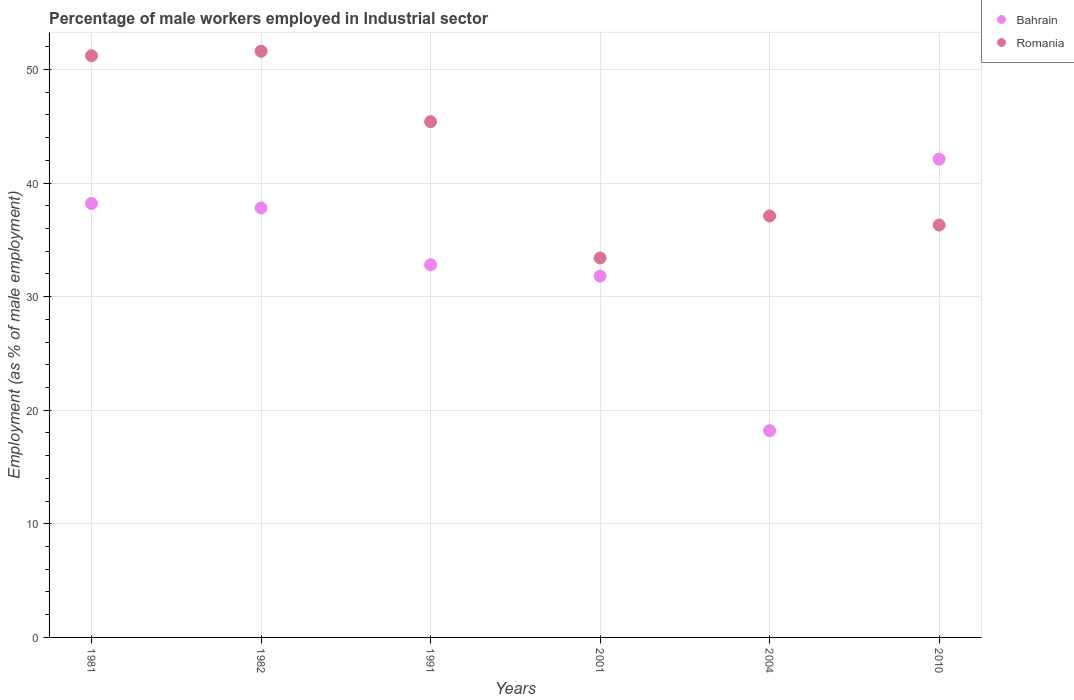How many different coloured dotlines are there?
Offer a terse response. 2. What is the percentage of male workers employed in Industrial sector in Romania in 1982?
Give a very brief answer. 51.6. Across all years, what is the maximum percentage of male workers employed in Industrial sector in Romania?
Give a very brief answer. 51.6. Across all years, what is the minimum percentage of male workers employed in Industrial sector in Bahrain?
Make the answer very short. 18.2. In which year was the percentage of male workers employed in Industrial sector in Romania maximum?
Keep it short and to the point. 1982. In which year was the percentage of male workers employed in Industrial sector in Romania minimum?
Give a very brief answer. 2001. What is the total percentage of male workers employed in Industrial sector in Romania in the graph?
Provide a succinct answer. 255. What is the difference between the percentage of male workers employed in Industrial sector in Bahrain in 1991 and that in 2010?
Provide a succinct answer. -9.3. What is the difference between the percentage of male workers employed in Industrial sector in Romania in 2004 and the percentage of male workers employed in Industrial sector in Bahrain in 1981?
Offer a terse response. -1.1. What is the average percentage of male workers employed in Industrial sector in Romania per year?
Offer a very short reply. 42.5. In the year 2004, what is the difference between the percentage of male workers employed in Industrial sector in Romania and percentage of male workers employed in Industrial sector in Bahrain?
Provide a succinct answer. 18.9. What is the ratio of the percentage of male workers employed in Industrial sector in Bahrain in 1981 to that in 2010?
Make the answer very short. 0.91. Is the difference between the percentage of male workers employed in Industrial sector in Romania in 1991 and 2010 greater than the difference between the percentage of male workers employed in Industrial sector in Bahrain in 1991 and 2010?
Your response must be concise. Yes. What is the difference between the highest and the second highest percentage of male workers employed in Industrial sector in Romania?
Your response must be concise. 0.4. What is the difference between the highest and the lowest percentage of male workers employed in Industrial sector in Romania?
Provide a succinct answer. 18.2. Does the percentage of male workers employed in Industrial sector in Romania monotonically increase over the years?
Make the answer very short. No. Is the percentage of male workers employed in Industrial sector in Romania strictly greater than the percentage of male workers employed in Industrial sector in Bahrain over the years?
Offer a terse response. No. How many years are there in the graph?
Your response must be concise. 6. What is the difference between two consecutive major ticks on the Y-axis?
Your response must be concise. 10. What is the title of the graph?
Provide a short and direct response. Percentage of male workers employed in Industrial sector. What is the label or title of the X-axis?
Make the answer very short. Years. What is the label or title of the Y-axis?
Ensure brevity in your answer.  Employment (as % of male employment). What is the Employment (as % of male employment) in Bahrain in 1981?
Provide a succinct answer. 38.2. What is the Employment (as % of male employment) of Romania in 1981?
Provide a short and direct response. 51.2. What is the Employment (as % of male employment) of Bahrain in 1982?
Offer a terse response. 37.8. What is the Employment (as % of male employment) in Romania in 1982?
Provide a succinct answer. 51.6. What is the Employment (as % of male employment) in Bahrain in 1991?
Provide a short and direct response. 32.8. What is the Employment (as % of male employment) of Romania in 1991?
Provide a succinct answer. 45.4. What is the Employment (as % of male employment) of Bahrain in 2001?
Offer a very short reply. 31.8. What is the Employment (as % of male employment) in Romania in 2001?
Your answer should be very brief. 33.4. What is the Employment (as % of male employment) in Bahrain in 2004?
Make the answer very short. 18.2. What is the Employment (as % of male employment) in Romania in 2004?
Offer a terse response. 37.1. What is the Employment (as % of male employment) in Bahrain in 2010?
Keep it short and to the point. 42.1. What is the Employment (as % of male employment) in Romania in 2010?
Provide a short and direct response. 36.3. Across all years, what is the maximum Employment (as % of male employment) of Bahrain?
Offer a terse response. 42.1. Across all years, what is the maximum Employment (as % of male employment) of Romania?
Keep it short and to the point. 51.6. Across all years, what is the minimum Employment (as % of male employment) of Bahrain?
Provide a succinct answer. 18.2. Across all years, what is the minimum Employment (as % of male employment) in Romania?
Offer a very short reply. 33.4. What is the total Employment (as % of male employment) in Bahrain in the graph?
Give a very brief answer. 200.9. What is the total Employment (as % of male employment) of Romania in the graph?
Give a very brief answer. 255. What is the difference between the Employment (as % of male employment) in Romania in 1981 and that in 1982?
Keep it short and to the point. -0.4. What is the difference between the Employment (as % of male employment) of Bahrain in 1981 and that in 1991?
Provide a short and direct response. 5.4. What is the difference between the Employment (as % of male employment) of Romania in 1981 and that in 2001?
Offer a very short reply. 17.8. What is the difference between the Employment (as % of male employment) of Bahrain in 1981 and that in 2004?
Your answer should be very brief. 20. What is the difference between the Employment (as % of male employment) in Romania in 1981 and that in 2004?
Your response must be concise. 14.1. What is the difference between the Employment (as % of male employment) of Bahrain in 1981 and that in 2010?
Provide a short and direct response. -3.9. What is the difference between the Employment (as % of male employment) of Romania in 1981 and that in 2010?
Give a very brief answer. 14.9. What is the difference between the Employment (as % of male employment) in Romania in 1982 and that in 1991?
Your response must be concise. 6.2. What is the difference between the Employment (as % of male employment) in Romania in 1982 and that in 2001?
Your response must be concise. 18.2. What is the difference between the Employment (as % of male employment) of Bahrain in 1982 and that in 2004?
Provide a succinct answer. 19.6. What is the difference between the Employment (as % of male employment) of Romania in 1982 and that in 2004?
Your answer should be compact. 14.5. What is the difference between the Employment (as % of male employment) of Bahrain in 1982 and that in 2010?
Provide a short and direct response. -4.3. What is the difference between the Employment (as % of male employment) of Bahrain in 1991 and that in 2004?
Provide a succinct answer. 14.6. What is the difference between the Employment (as % of male employment) of Romania in 1991 and that in 2004?
Offer a terse response. 8.3. What is the difference between the Employment (as % of male employment) in Bahrain in 1991 and that in 2010?
Keep it short and to the point. -9.3. What is the difference between the Employment (as % of male employment) in Romania in 1991 and that in 2010?
Keep it short and to the point. 9.1. What is the difference between the Employment (as % of male employment) of Bahrain in 2001 and that in 2004?
Provide a short and direct response. 13.6. What is the difference between the Employment (as % of male employment) of Romania in 2001 and that in 2004?
Provide a succinct answer. -3.7. What is the difference between the Employment (as % of male employment) in Bahrain in 2001 and that in 2010?
Make the answer very short. -10.3. What is the difference between the Employment (as % of male employment) of Romania in 2001 and that in 2010?
Offer a terse response. -2.9. What is the difference between the Employment (as % of male employment) in Bahrain in 2004 and that in 2010?
Offer a terse response. -23.9. What is the difference between the Employment (as % of male employment) in Bahrain in 1981 and the Employment (as % of male employment) in Romania in 1982?
Offer a very short reply. -13.4. What is the difference between the Employment (as % of male employment) in Bahrain in 1981 and the Employment (as % of male employment) in Romania in 1991?
Provide a succinct answer. -7.2. What is the difference between the Employment (as % of male employment) of Bahrain in 1981 and the Employment (as % of male employment) of Romania in 2001?
Give a very brief answer. 4.8. What is the difference between the Employment (as % of male employment) of Bahrain in 1981 and the Employment (as % of male employment) of Romania in 2004?
Provide a succinct answer. 1.1. What is the difference between the Employment (as % of male employment) in Bahrain in 1982 and the Employment (as % of male employment) in Romania in 2004?
Make the answer very short. 0.7. What is the difference between the Employment (as % of male employment) of Bahrain in 1982 and the Employment (as % of male employment) of Romania in 2010?
Offer a terse response. 1.5. What is the difference between the Employment (as % of male employment) in Bahrain in 1991 and the Employment (as % of male employment) in Romania in 2004?
Your answer should be very brief. -4.3. What is the difference between the Employment (as % of male employment) in Bahrain in 2001 and the Employment (as % of male employment) in Romania in 2004?
Offer a terse response. -5.3. What is the difference between the Employment (as % of male employment) of Bahrain in 2004 and the Employment (as % of male employment) of Romania in 2010?
Offer a very short reply. -18.1. What is the average Employment (as % of male employment) in Bahrain per year?
Offer a terse response. 33.48. What is the average Employment (as % of male employment) in Romania per year?
Your answer should be compact. 42.5. In the year 1982, what is the difference between the Employment (as % of male employment) of Bahrain and Employment (as % of male employment) of Romania?
Provide a succinct answer. -13.8. In the year 1991, what is the difference between the Employment (as % of male employment) of Bahrain and Employment (as % of male employment) of Romania?
Offer a very short reply. -12.6. In the year 2001, what is the difference between the Employment (as % of male employment) of Bahrain and Employment (as % of male employment) of Romania?
Your answer should be very brief. -1.6. In the year 2004, what is the difference between the Employment (as % of male employment) in Bahrain and Employment (as % of male employment) in Romania?
Your answer should be compact. -18.9. In the year 2010, what is the difference between the Employment (as % of male employment) in Bahrain and Employment (as % of male employment) in Romania?
Your answer should be compact. 5.8. What is the ratio of the Employment (as % of male employment) of Bahrain in 1981 to that in 1982?
Your answer should be very brief. 1.01. What is the ratio of the Employment (as % of male employment) in Bahrain in 1981 to that in 1991?
Offer a terse response. 1.16. What is the ratio of the Employment (as % of male employment) of Romania in 1981 to that in 1991?
Keep it short and to the point. 1.13. What is the ratio of the Employment (as % of male employment) of Bahrain in 1981 to that in 2001?
Offer a terse response. 1.2. What is the ratio of the Employment (as % of male employment) of Romania in 1981 to that in 2001?
Make the answer very short. 1.53. What is the ratio of the Employment (as % of male employment) of Bahrain in 1981 to that in 2004?
Offer a very short reply. 2.1. What is the ratio of the Employment (as % of male employment) of Romania in 1981 to that in 2004?
Provide a succinct answer. 1.38. What is the ratio of the Employment (as % of male employment) in Bahrain in 1981 to that in 2010?
Provide a short and direct response. 0.91. What is the ratio of the Employment (as % of male employment) of Romania in 1981 to that in 2010?
Your answer should be compact. 1.41. What is the ratio of the Employment (as % of male employment) of Bahrain in 1982 to that in 1991?
Your answer should be compact. 1.15. What is the ratio of the Employment (as % of male employment) in Romania in 1982 to that in 1991?
Offer a terse response. 1.14. What is the ratio of the Employment (as % of male employment) of Bahrain in 1982 to that in 2001?
Your answer should be compact. 1.19. What is the ratio of the Employment (as % of male employment) of Romania in 1982 to that in 2001?
Your response must be concise. 1.54. What is the ratio of the Employment (as % of male employment) in Bahrain in 1982 to that in 2004?
Your answer should be very brief. 2.08. What is the ratio of the Employment (as % of male employment) of Romania in 1982 to that in 2004?
Your response must be concise. 1.39. What is the ratio of the Employment (as % of male employment) in Bahrain in 1982 to that in 2010?
Offer a very short reply. 0.9. What is the ratio of the Employment (as % of male employment) in Romania in 1982 to that in 2010?
Your answer should be very brief. 1.42. What is the ratio of the Employment (as % of male employment) in Bahrain in 1991 to that in 2001?
Make the answer very short. 1.03. What is the ratio of the Employment (as % of male employment) in Romania in 1991 to that in 2001?
Offer a very short reply. 1.36. What is the ratio of the Employment (as % of male employment) in Bahrain in 1991 to that in 2004?
Give a very brief answer. 1.8. What is the ratio of the Employment (as % of male employment) of Romania in 1991 to that in 2004?
Your answer should be very brief. 1.22. What is the ratio of the Employment (as % of male employment) in Bahrain in 1991 to that in 2010?
Your response must be concise. 0.78. What is the ratio of the Employment (as % of male employment) of Romania in 1991 to that in 2010?
Give a very brief answer. 1.25. What is the ratio of the Employment (as % of male employment) in Bahrain in 2001 to that in 2004?
Your response must be concise. 1.75. What is the ratio of the Employment (as % of male employment) of Romania in 2001 to that in 2004?
Keep it short and to the point. 0.9. What is the ratio of the Employment (as % of male employment) of Bahrain in 2001 to that in 2010?
Provide a short and direct response. 0.76. What is the ratio of the Employment (as % of male employment) in Romania in 2001 to that in 2010?
Your answer should be very brief. 0.92. What is the ratio of the Employment (as % of male employment) of Bahrain in 2004 to that in 2010?
Offer a very short reply. 0.43. What is the ratio of the Employment (as % of male employment) of Romania in 2004 to that in 2010?
Provide a short and direct response. 1.02. What is the difference between the highest and the second highest Employment (as % of male employment) in Romania?
Your response must be concise. 0.4. What is the difference between the highest and the lowest Employment (as % of male employment) in Bahrain?
Your response must be concise. 23.9. 